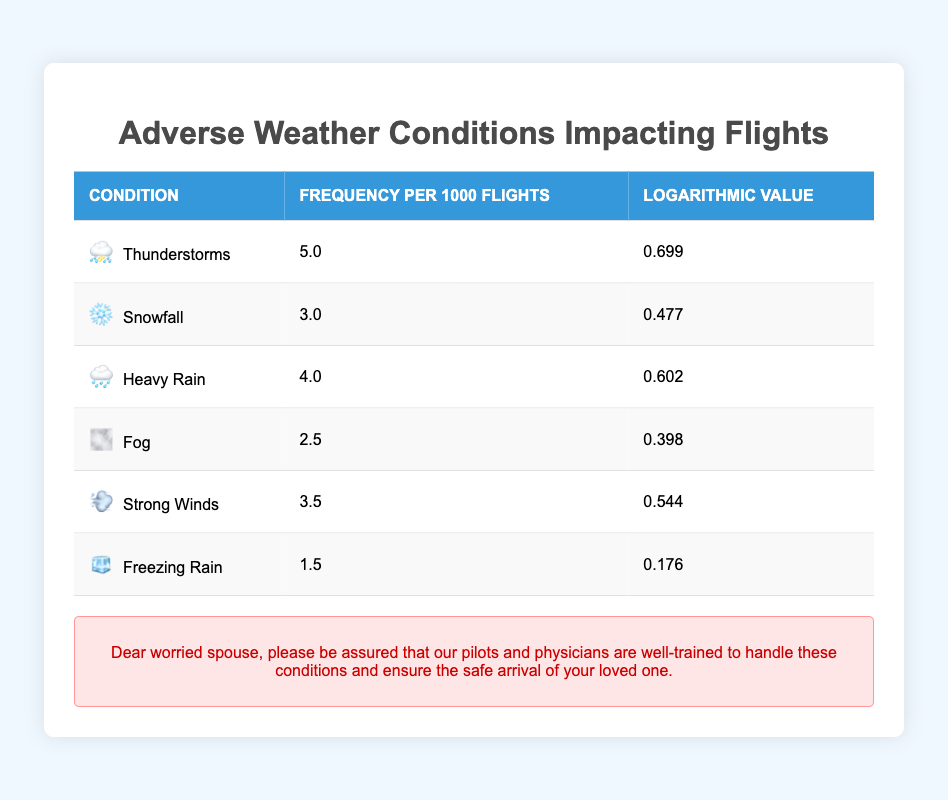What is the frequency of thunderstorms per 1000 flights? According to the table, the frequency of thunderstorms is listed directly under the "Frequency per 1000 Flights" column as 5.0.
Answer: 5.0 Which adverse weather condition has the lowest frequency per 1000 flights? By checking the "Frequency per 1000 Flights" column, we can see that Freezing Rain has the lowest frequency at 1.5 among all the conditions listed.
Answer: Freezing Rain What is the sum of the frequencies of heavy rain and snowfall? The frequency of heavy rain is 4.0 and the frequency of snowfall is 3.0. Adding these two values gives us 4.0 + 3.0 = 7.0.
Answer: 7.0 Is the logarithmic value for strong winds higher than that for fog? The logarithmic value for strong winds is 0.544, while for fog it is 0.398. Since 0.544 is greater than 0.398, the statement is true.
Answer: Yes What is the average frequency of the listed adverse weather conditions? To find the average frequency, we first sum the frequencies: 5.0 + 3.0 + 4.0 + 2.5 + 3.5 + 1.5 = 20.5. There are 6 conditions, so we divide the total by 6: 20.5 / 6 = 3.41667, which we round to 3.42 for simplicity.
Answer: 3.42 Which adverse weather condition has a logarithmic value closest to 0.5? By examining the "Logarithmic Value" column, we find that heavy rain has a logarithmic value of 0.602, which is closest to 0.5 compared to the other conditions.
Answer: Heavy Rain How many adverse weather conditions have a frequency greater than 3.0 per 1000 flights? Looking at the "Frequency per 1000 Flights" column, we see that there are three conditions (Thunderstorms, Heavy Rain, and Strong Winds) listed with frequencies greater than 3.0: 5.0, 4.0, and 3.5 respectively.
Answer: 3 What is the difference in frequency between thunderstorms and freezing rain? By checking the frequencies, thunderstorms have a frequency of 5.0 and freezing rain has a frequency of 1.5. The difference is calculated as 5.0 - 1.5 = 3.5.
Answer: 3.5 In total, how many conditions have a logarithmic value below 0.4? By reviewing the "Logarithmic Value" column, we find that only Freezing Rain (0.176) and Fog (0.398) fall below 0.4. Thus, there are 2 conditions in total.
Answer: 2 